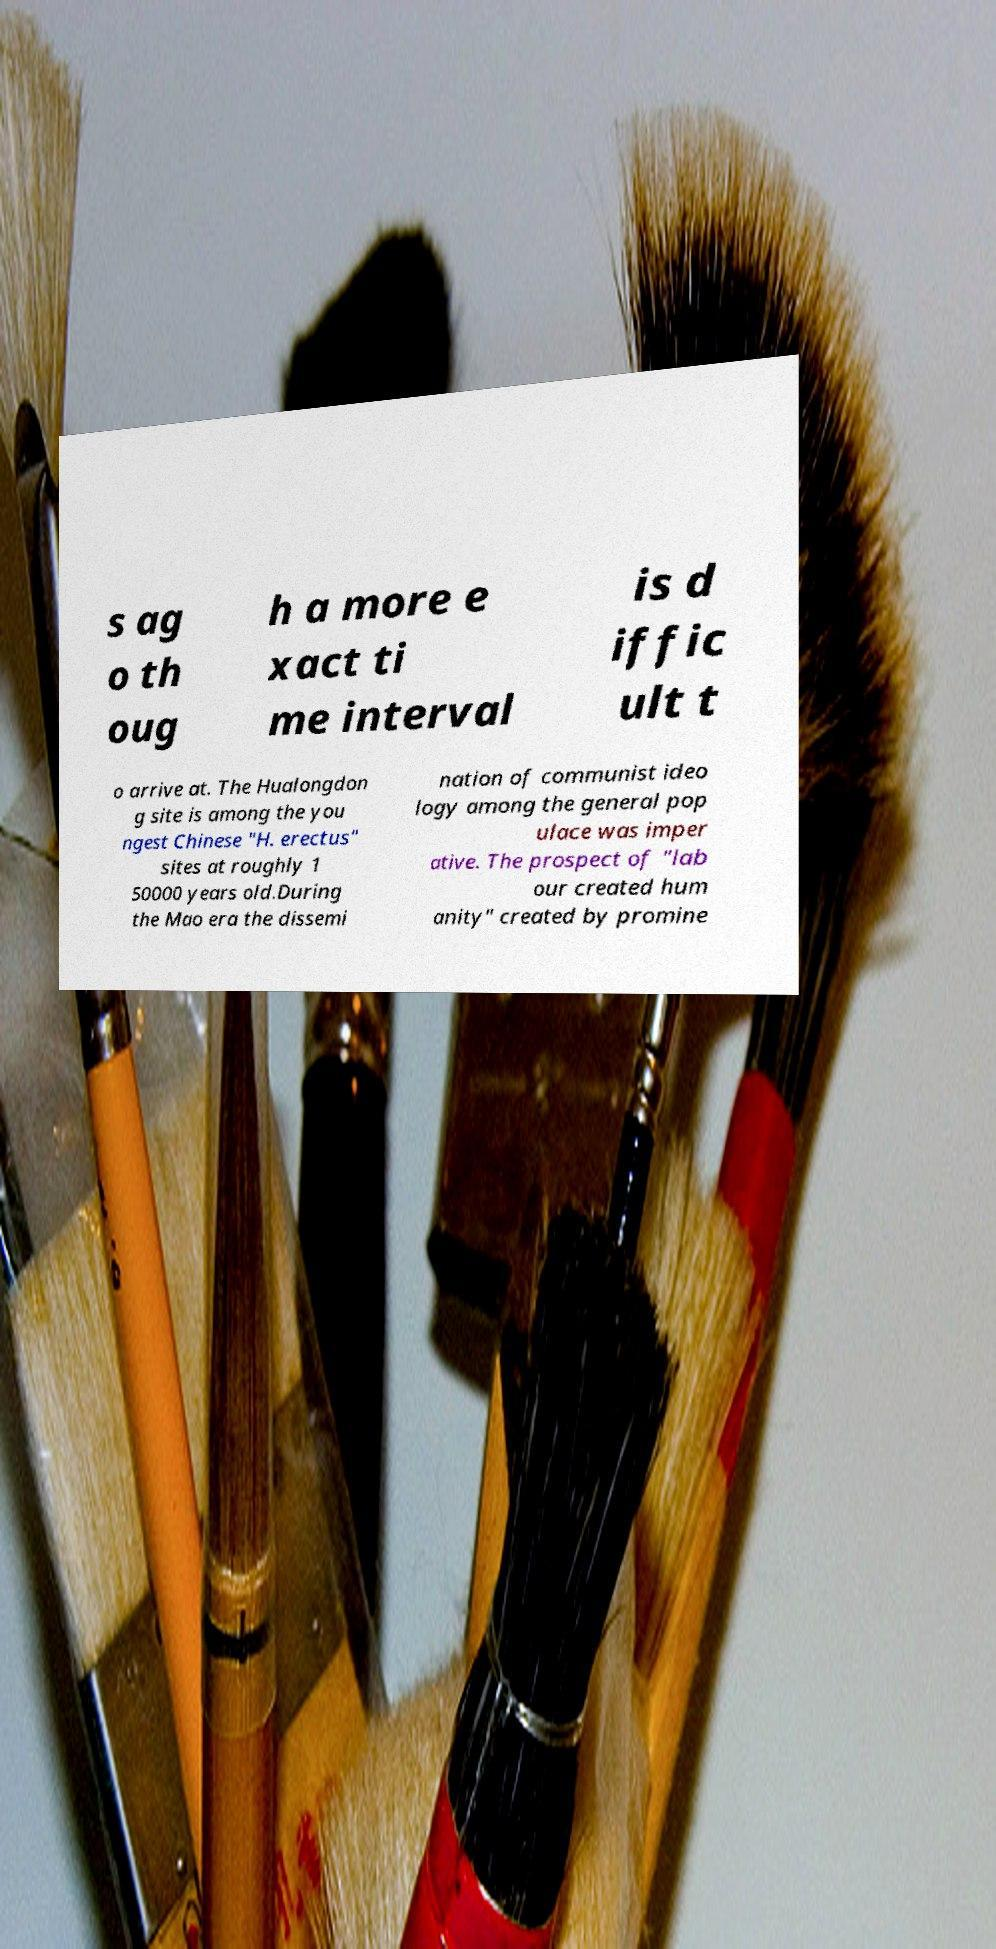Can you accurately transcribe the text from the provided image for me? s ag o th oug h a more e xact ti me interval is d iffic ult t o arrive at. The Hualongdon g site is among the you ngest Chinese "H. erectus" sites at roughly 1 50000 years old.During the Mao era the dissemi nation of communist ideo logy among the general pop ulace was imper ative. The prospect of "lab our created hum anity" created by promine 